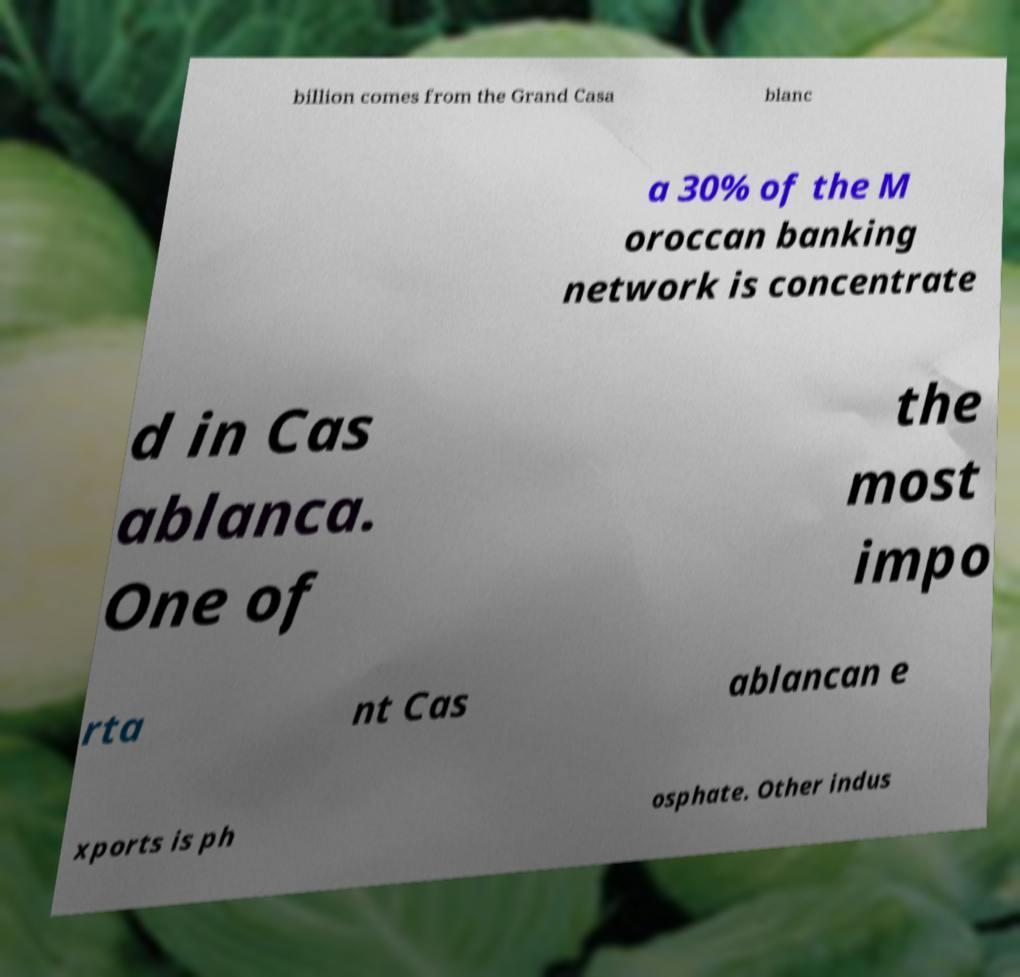I need the written content from this picture converted into text. Can you do that? billion comes from the Grand Casa blanc a 30% of the M oroccan banking network is concentrate d in Cas ablanca. One of the most impo rta nt Cas ablancan e xports is ph osphate. Other indus 